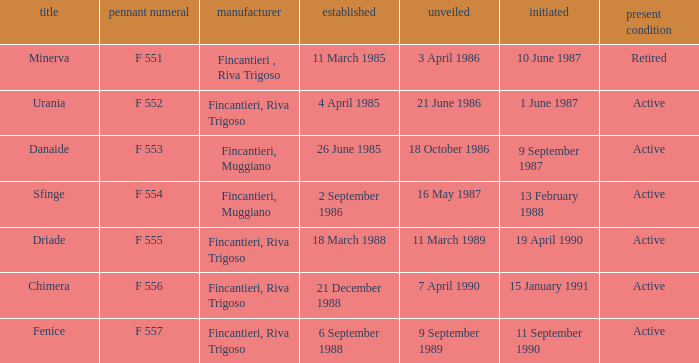Which launch date involved the Driade? 11 March 1989. 